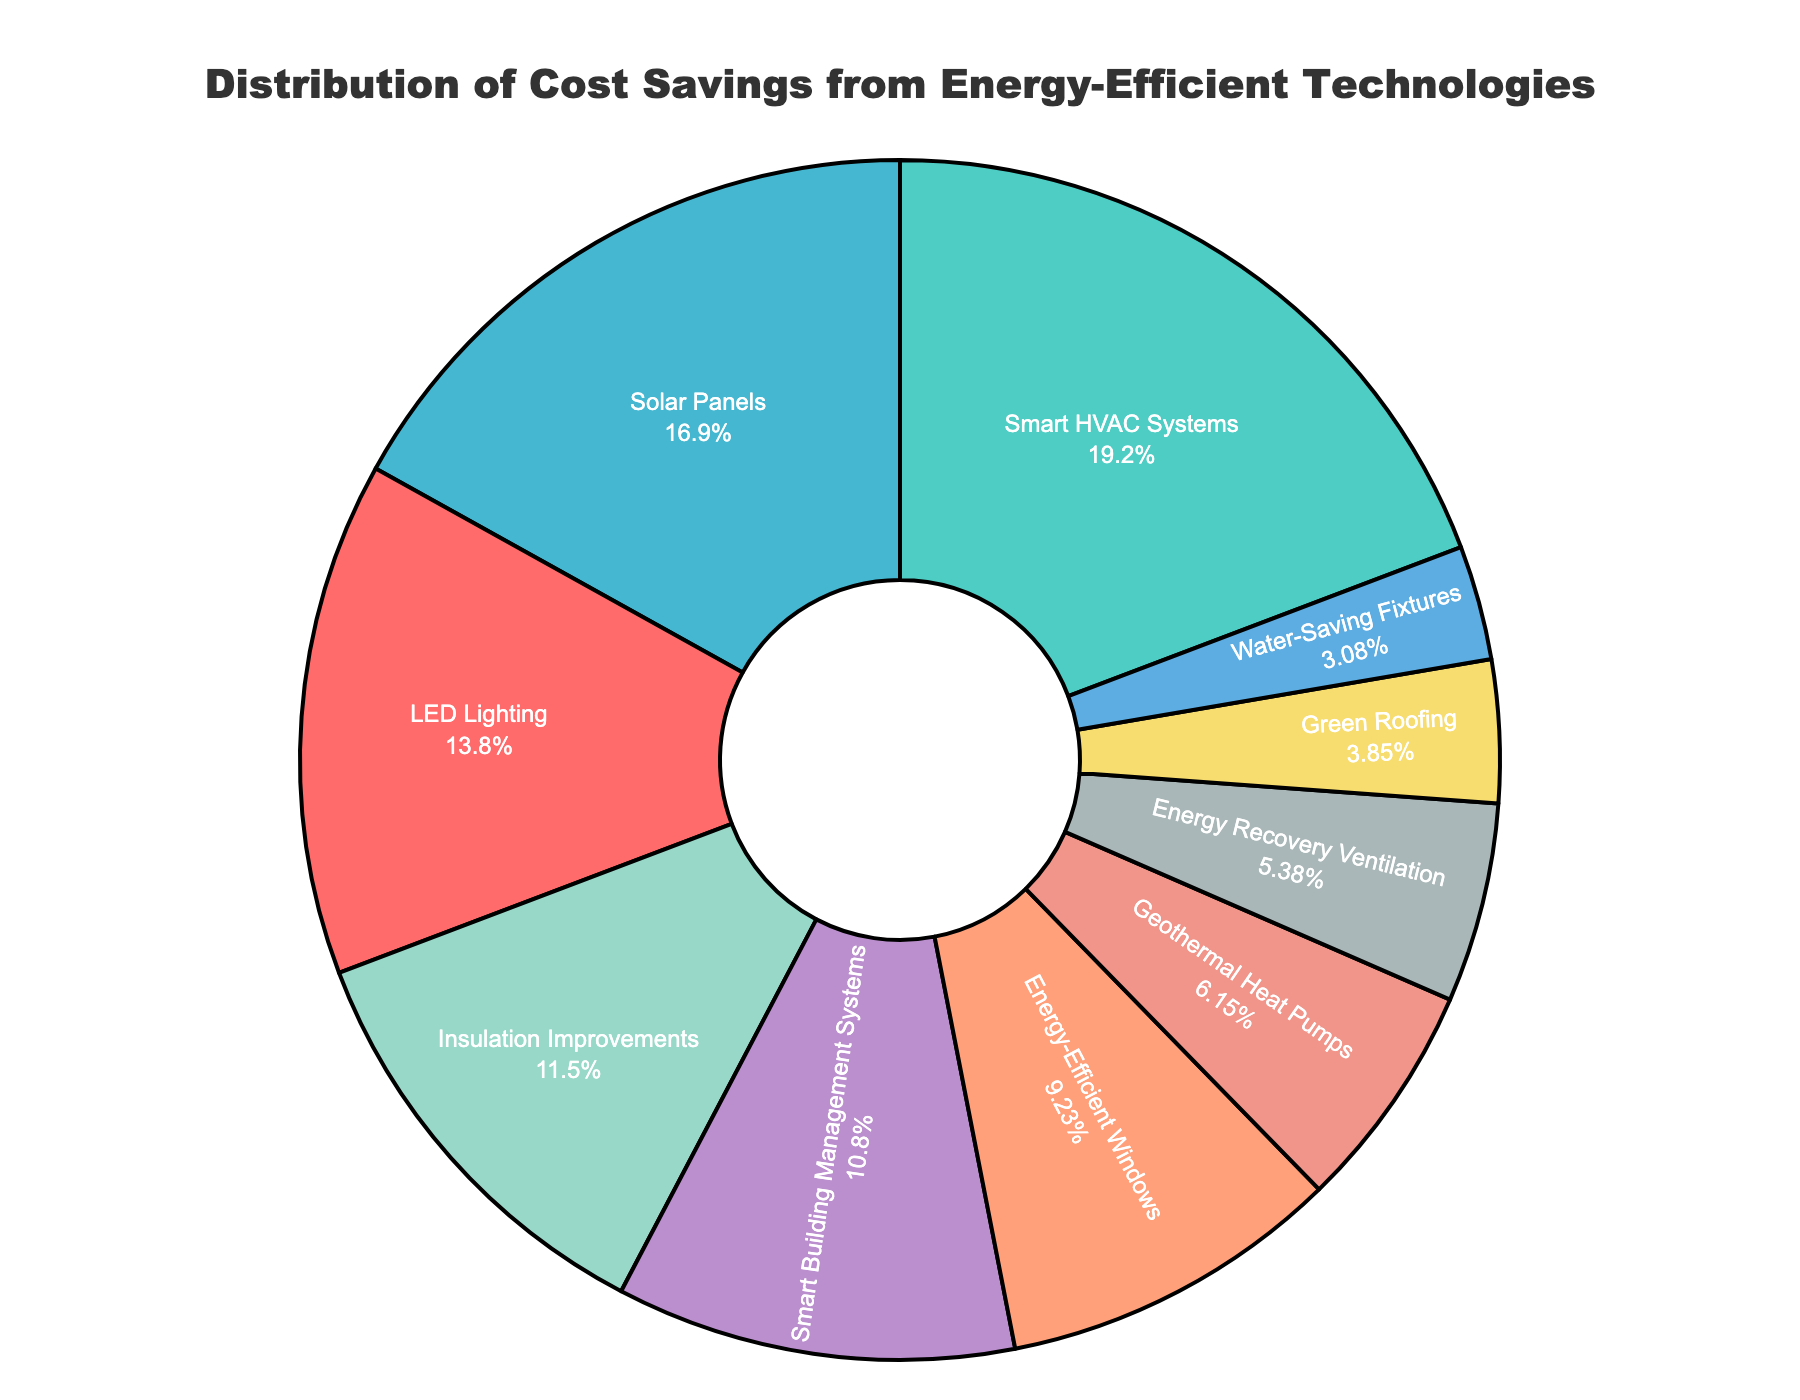What's the percentage of total savings contributed by LED Lighting and Energy-Efficient Windows combined? To find the total savings from both technologies, sum their percentages: 18% (LED Lighting) + 12% (Energy-Efficient Windows) = 30%.
Answer: 30% Which technology has the highest percentage of cost savings? Identify the slice in the pie chart with the largest value, which is Smart HVAC Systems at 25%.
Answer: Smart HVAC Systems How much more in percentage of cost savings do Solar Panels provide compared to Insulation Improvements? Find the difference between the percentages of Solar Panels (22%) and Insulation Improvements (15%): 22% - 15% = 7%.
Answer: 7% What is the percentage difference between the highest and lowest technologies in terms of cost savings? The highest is Smart HVAC Systems at 25%, and the lowest is Water-Saving Fixtures at 4%. The difference is 25% - 4% = 21%.
Answer: 21% Which technology contributes the least to cost savings, and what is its percentage? Identify the smallest slice in the pie chart, which is Water-Saving Fixtures at 4%.
Answer: Water-Saving Fixtures, 4% What is the combined percentage contribution of technologies that individually contribute less than 10% to cost savings? Sum the percentages of Green Roofing (5%), Water-Saving Fixtures (4%), Geothermal Heat Pumps (8%), and Energy Recovery Ventilation (7%): 5% + 4% + 8% + 7% = 24%.
Answer: 24% How does the percentage contribution of Smart Building Management Systems compare to that of Insulation Improvements? Compare the two percentages: Smart Building Management Systems (14%) is less than Insulation Improvements (15%) by 1%.
Answer: Smart Building Management Systems contributes 1% less How many technologies contribute more than 15% each to cost savings? Identify the technologies with percentages greater than 15%: LED Lighting (18%), Smart HVAC Systems (25%), and Solar Panels (22%) are the only ones.
Answer: 3 technologies Between Energy Recovery Ventilation and Smart Building Management Systems, which contributes more to cost savings, and by what percentage? Compare their percentages: Smart Building Management Systems (14%) contributes more than Energy Recovery Ventilation (7%). The difference is 14% - 7% = 7%.
Answer: Smart Building Management Systems by 7% What is the visual prominence of the technology with the second-highest percentage in the pie chart? The technology with the second-highest percentage is Solar Panels (22%). It is visually prominent as the second-largest slice in the pie chart.
Answer: High visual prominence 